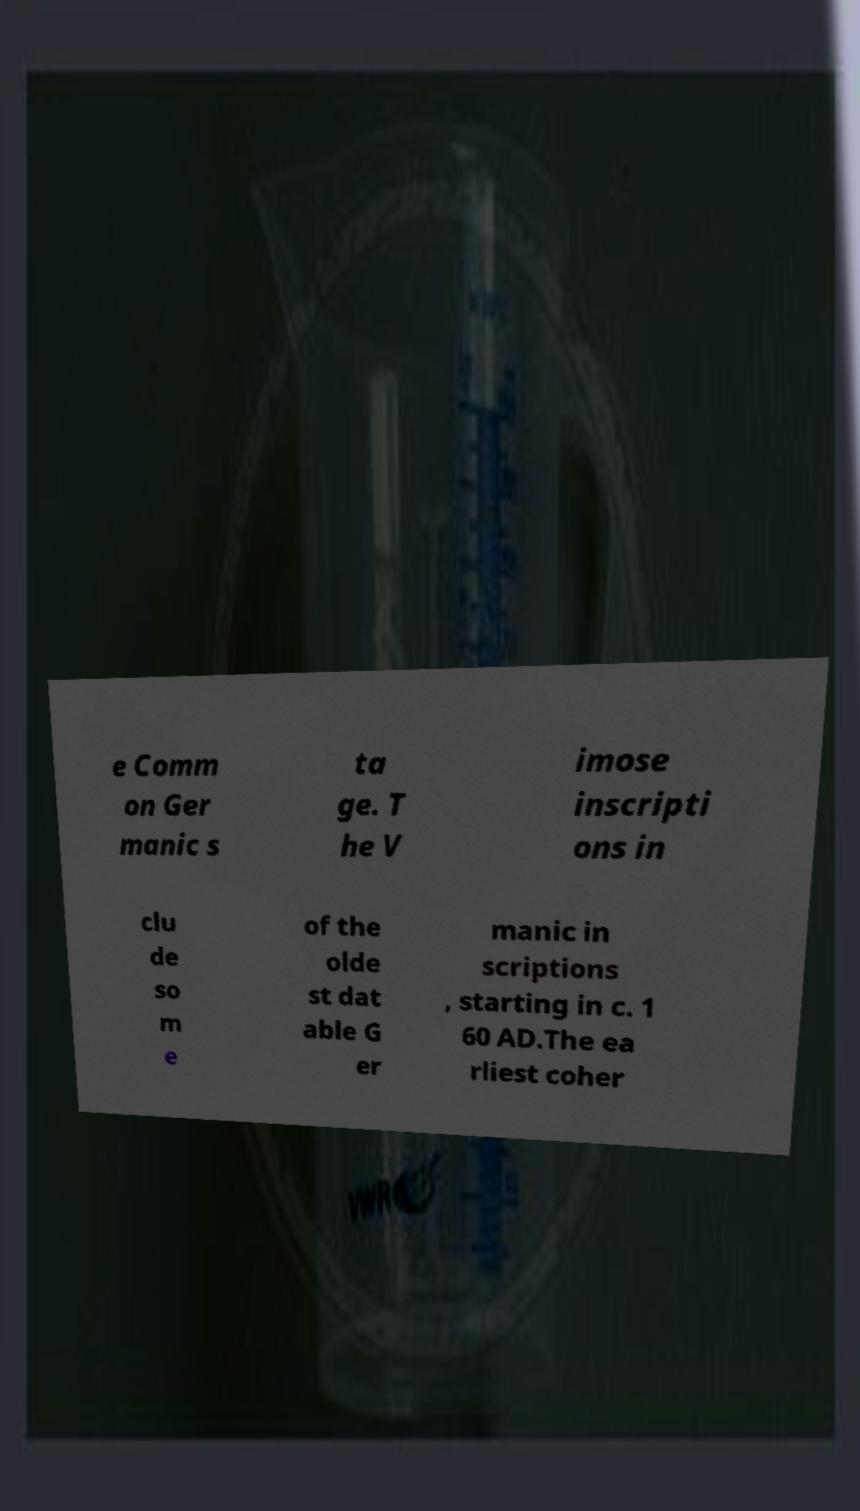For documentation purposes, I need the text within this image transcribed. Could you provide that? e Comm on Ger manic s ta ge. T he V imose inscripti ons in clu de so m e of the olde st dat able G er manic in scriptions , starting in c. 1 60 AD.The ea rliest coher 